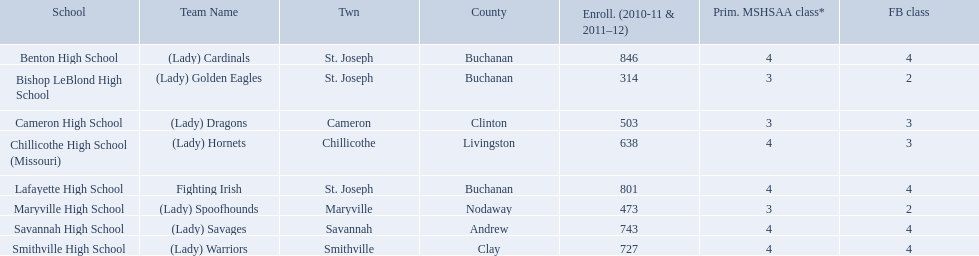What team uses green and grey as colors? Fighting Irish. What is this team called? Lafayette High School. Could you help me parse every detail presented in this table? {'header': ['School', 'Team Name', 'Twn', 'County', 'Enroll. (2010-11 & 2011–12)', 'Prim. MSHSAA class*', 'FB class'], 'rows': [['Benton High School', '(Lady) Cardinals', 'St. Joseph', 'Buchanan', '846', '4', '4'], ['Bishop LeBlond High School', '(Lady) Golden Eagles', 'St. Joseph', 'Buchanan', '314', '3', '2'], ['Cameron High School', '(Lady) Dragons', 'Cameron', 'Clinton', '503', '3', '3'], ['Chillicothe High School (Missouri)', '(Lady) Hornets', 'Chillicothe', 'Livingston', '638', '4', '3'], ['Lafayette High School', 'Fighting Irish', 'St. Joseph', 'Buchanan', '801', '4', '4'], ['Maryville High School', '(Lady) Spoofhounds', 'Maryville', 'Nodaway', '473', '3', '2'], ['Savannah High School', '(Lady) Savages', 'Savannah', 'Andrew', '743', '4', '4'], ['Smithville High School', '(Lady) Warriors', 'Smithville', 'Clay', '727', '4', '4']]} What schools are located in st. joseph? Benton High School, Bishop LeBlond High School, Lafayette High School. Which st. joseph schools have more then 800 enrollment  for 2010-11 7 2011-12? Benton High School, Lafayette High School. What is the name of the st. joseph school with 800 or more enrollment's team names is a not a (lady)? Lafayette High School. What school in midland empire conference has 846 students enrolled? Benton High School. What school has 314 students enrolled? Bishop LeBlond High School. What school had 638 students enrolled? Chillicothe High School (Missouri). What are the names of the schools? Benton High School, Bishop LeBlond High School, Cameron High School, Chillicothe High School (Missouri), Lafayette High School, Maryville High School, Savannah High School, Smithville High School. Of those, which had a total enrollment of less than 500? Bishop LeBlond High School, Maryville High School. And of those, which had the lowest enrollment? Bishop LeBlond High School. 